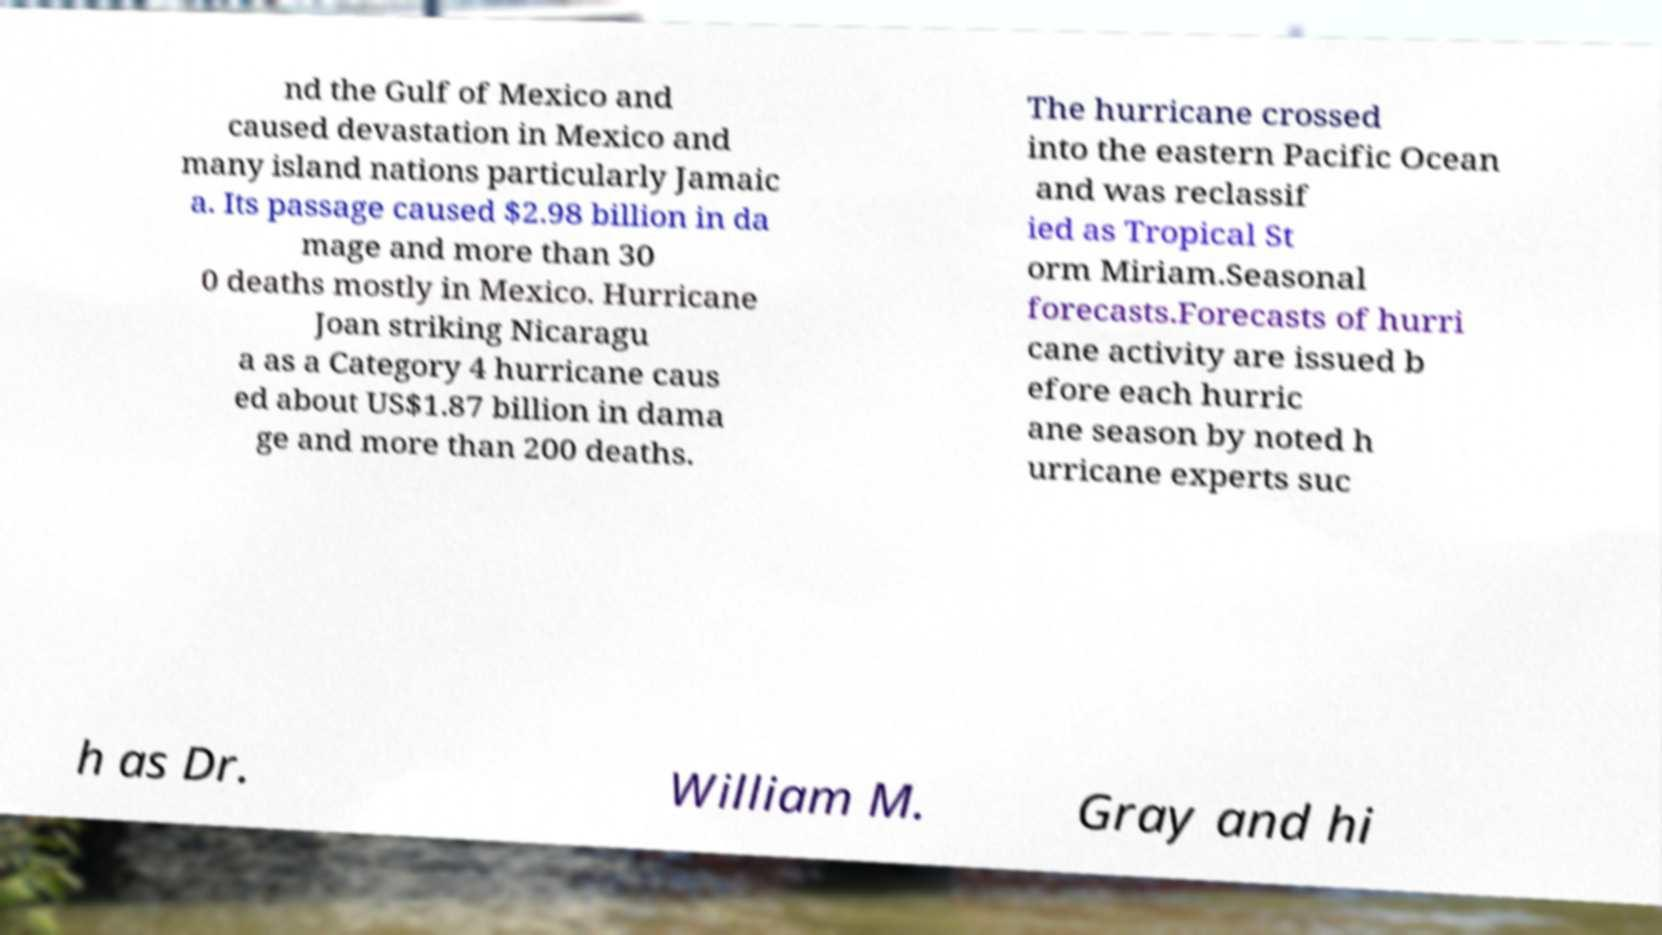For documentation purposes, I need the text within this image transcribed. Could you provide that? nd the Gulf of Mexico and caused devastation in Mexico and many island nations particularly Jamaic a. Its passage caused $2.98 billion in da mage and more than 30 0 deaths mostly in Mexico. Hurricane Joan striking Nicaragu a as a Category 4 hurricane caus ed about US$1.87 billion in dama ge and more than 200 deaths. The hurricane crossed into the eastern Pacific Ocean and was reclassif ied as Tropical St orm Miriam.Seasonal forecasts.Forecasts of hurri cane activity are issued b efore each hurric ane season by noted h urricane experts suc h as Dr. William M. Gray and hi 